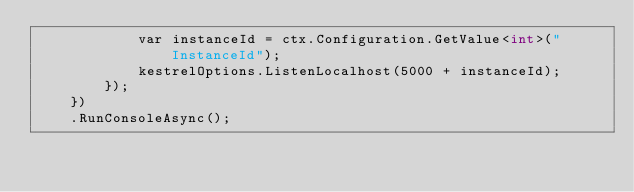<code> <loc_0><loc_0><loc_500><loc_500><_C#_>            var instanceId = ctx.Configuration.GetValue<int>("InstanceId");
            kestrelOptions.ListenLocalhost(5000 + instanceId);
        });
    })
    .RunConsoleAsync();
</code> 